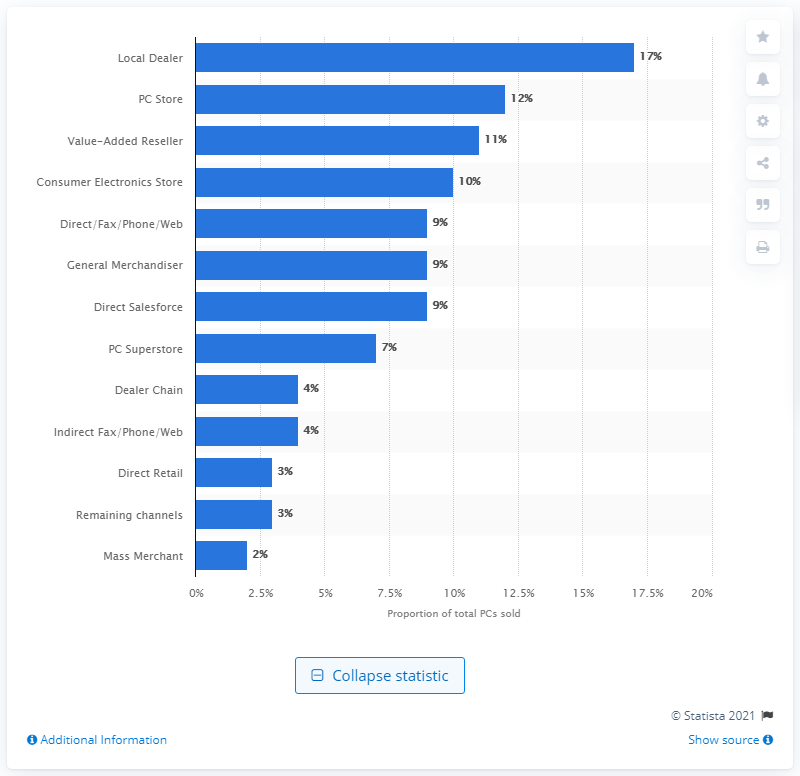Draw attention to some important aspects in this diagram. In 2010, consumer electronics stores accounted for approximately 10% of total PC sales. 